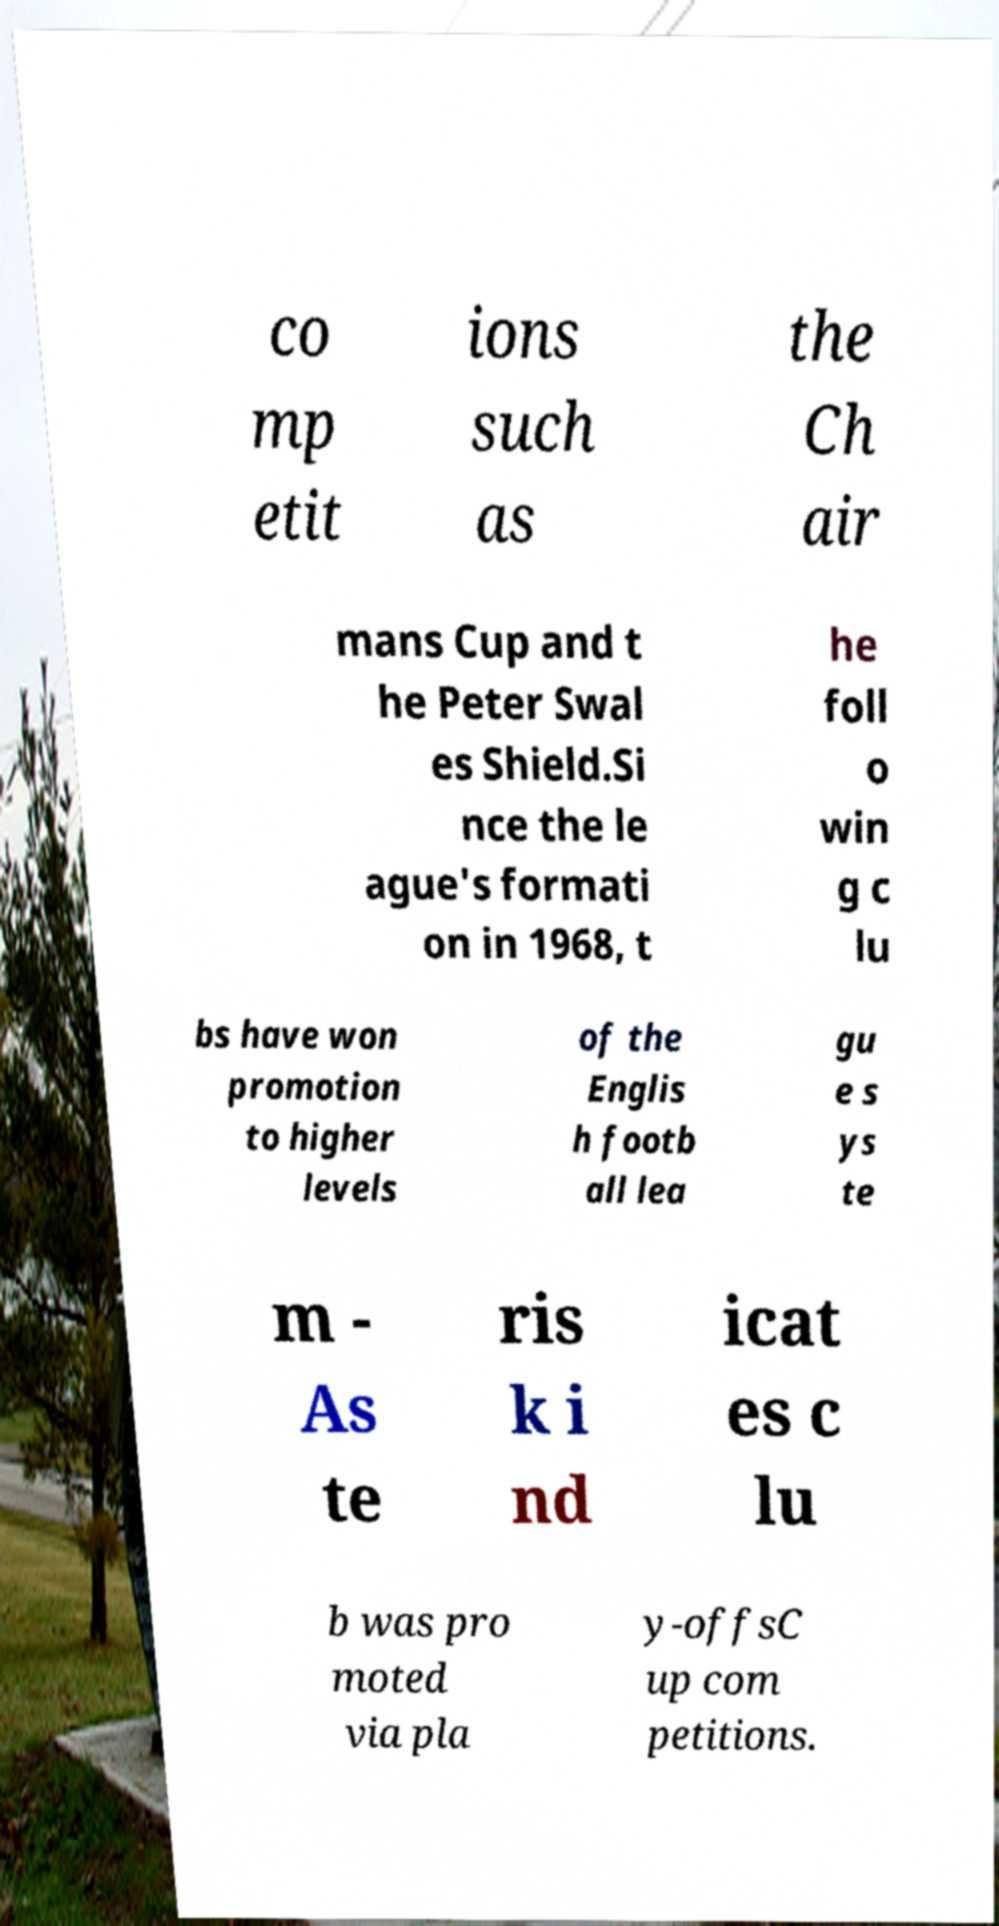Could you extract and type out the text from this image? co mp etit ions such as the Ch air mans Cup and t he Peter Swal es Shield.Si nce the le ague's formati on in 1968, t he foll o win g c lu bs have won promotion to higher levels of the Englis h footb all lea gu e s ys te m - As te ris k i nd icat es c lu b was pro moted via pla y-offsC up com petitions. 